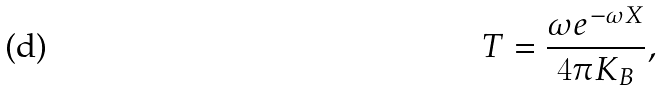<formula> <loc_0><loc_0><loc_500><loc_500>T = \frac { \omega e ^ { - \omega X } } { 4 \pi K _ { B } } ,</formula> 